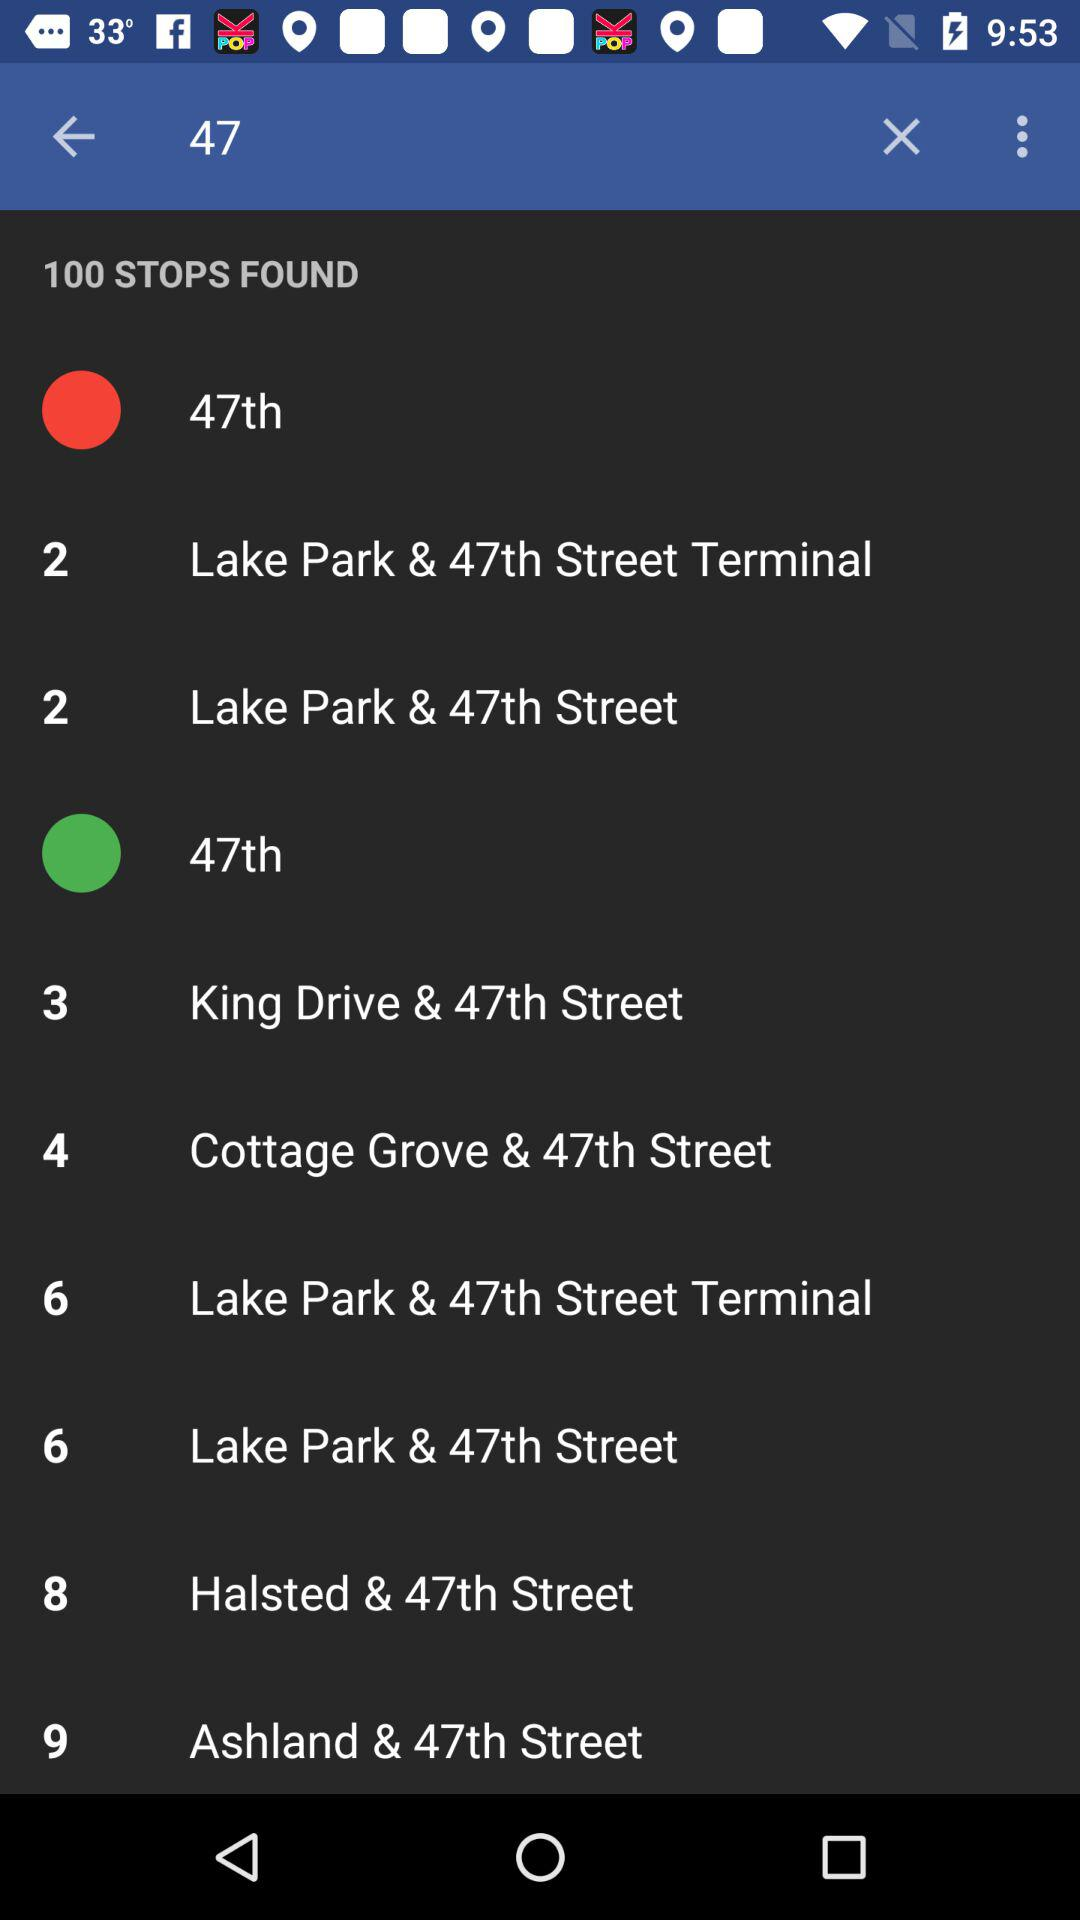What is the number of stops? The number of stops is 100. 